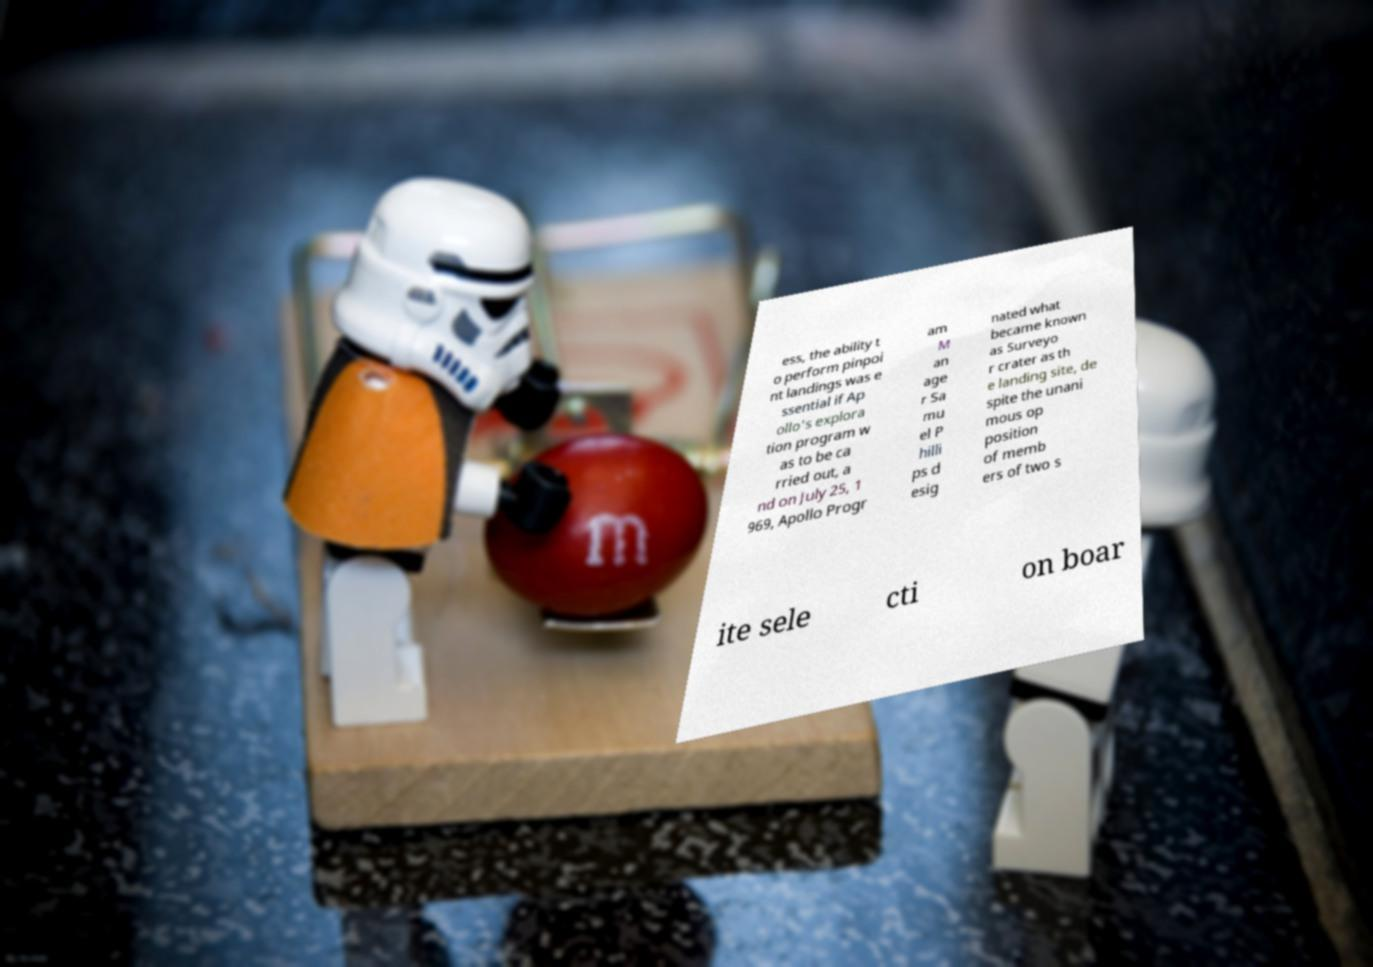What messages or text are displayed in this image? I need them in a readable, typed format. ess, the ability t o perform pinpoi nt landings was e ssential if Ap ollo's explora tion program w as to be ca rried out, a nd on July 25, 1 969, Apollo Progr am M an age r Sa mu el P hilli ps d esig nated what became known as Surveyo r crater as th e landing site, de spite the unani mous op position of memb ers of two s ite sele cti on boar 